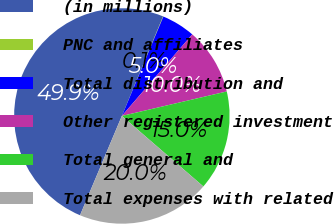Convert chart. <chart><loc_0><loc_0><loc_500><loc_500><pie_chart><fcel>(in millions)<fcel>PNC and affiliates<fcel>Total distribution and<fcel>Other registered investment<fcel>Total general and<fcel>Total expenses with related<nl><fcel>49.9%<fcel>0.05%<fcel>5.03%<fcel>10.02%<fcel>15.0%<fcel>19.99%<nl></chart> 